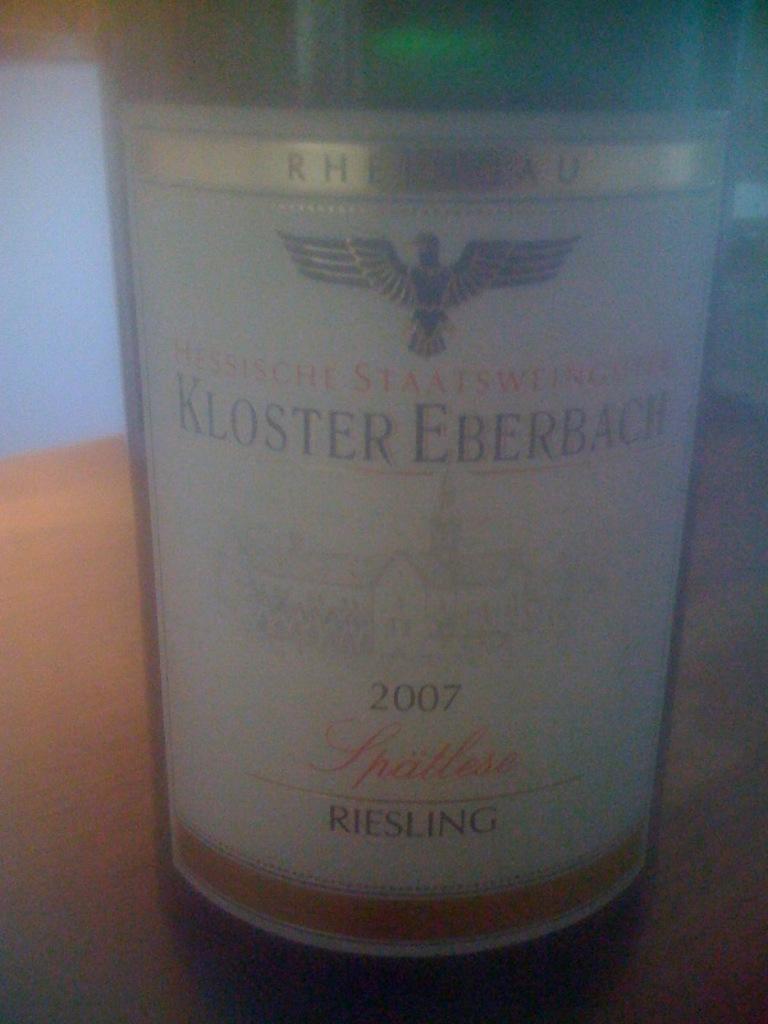Please provide a concise description of this image. This picture contains a green color glass bottle. On the bottle, we see a white sticker with text written is pasted. This bottle is placed on the brown table. Behind that, we see a wall in white color. 